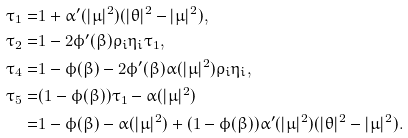Convert formula to latex. <formula><loc_0><loc_0><loc_500><loc_500>\tau _ { 1 } = & 1 + \alpha ^ { \prime } ( | \mu | ^ { 2 } ) ( | \theta | ^ { 2 } - | \mu | ^ { 2 } ) , \\ \tau _ { 2 } = & 1 - 2 \phi ^ { \prime } ( \beta ) \rho _ { i } \eta _ { i } \tau _ { 1 } , \\ \tau _ { 4 } = & 1 - \phi ( \beta ) - 2 \phi ^ { \prime } ( \beta ) \alpha ( | \mu | ^ { 2 } ) \rho _ { i } \eta _ { i } , \\ \tau _ { 5 } = & ( 1 - \phi ( \beta ) ) \tau _ { 1 } - \alpha ( | \mu | ^ { 2 } ) \\ = & 1 - \phi ( \beta ) - \alpha ( | \mu | ^ { 2 } ) + ( 1 - \phi ( \beta ) ) \alpha ^ { \prime } ( | \mu | ^ { 2 } ) ( | \theta | ^ { 2 } - | \mu | ^ { 2 } ) .</formula> 